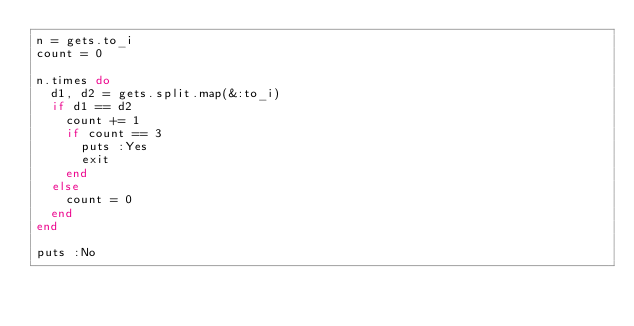Convert code to text. <code><loc_0><loc_0><loc_500><loc_500><_Ruby_>n = gets.to_i
count = 0

n.times do
  d1, d2 = gets.split.map(&:to_i)
  if d1 == d2
    count += 1
    if count == 3
      puts :Yes
      exit
    end
  else
    count = 0
  end
end

puts :No
</code> 